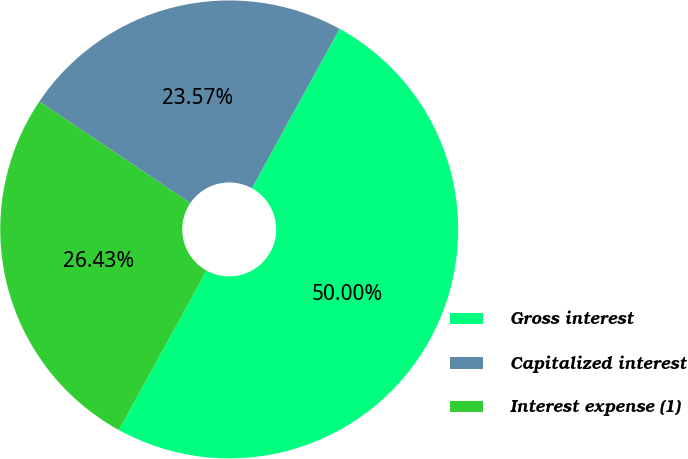<chart> <loc_0><loc_0><loc_500><loc_500><pie_chart><fcel>Gross interest<fcel>Capitalized interest<fcel>Interest expense (1)<nl><fcel>50.0%<fcel>23.57%<fcel>26.43%<nl></chart> 